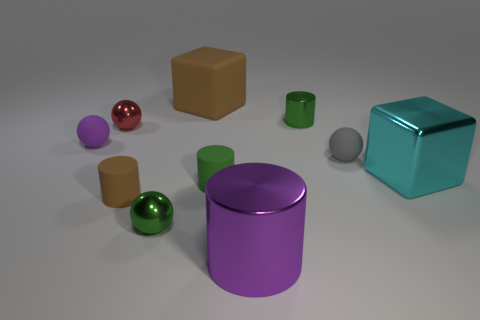Subtract all small cylinders. How many cylinders are left? 1 Subtract 2 cylinders. How many cylinders are left? 2 Subtract all blue spheres. Subtract all green cylinders. How many spheres are left? 4 Subtract all balls. How many objects are left? 6 Add 6 big cyan cubes. How many big cyan cubes exist? 7 Subtract 0 red blocks. How many objects are left? 10 Subtract all purple matte balls. Subtract all big cyan blocks. How many objects are left? 8 Add 4 tiny green balls. How many tiny green balls are left? 5 